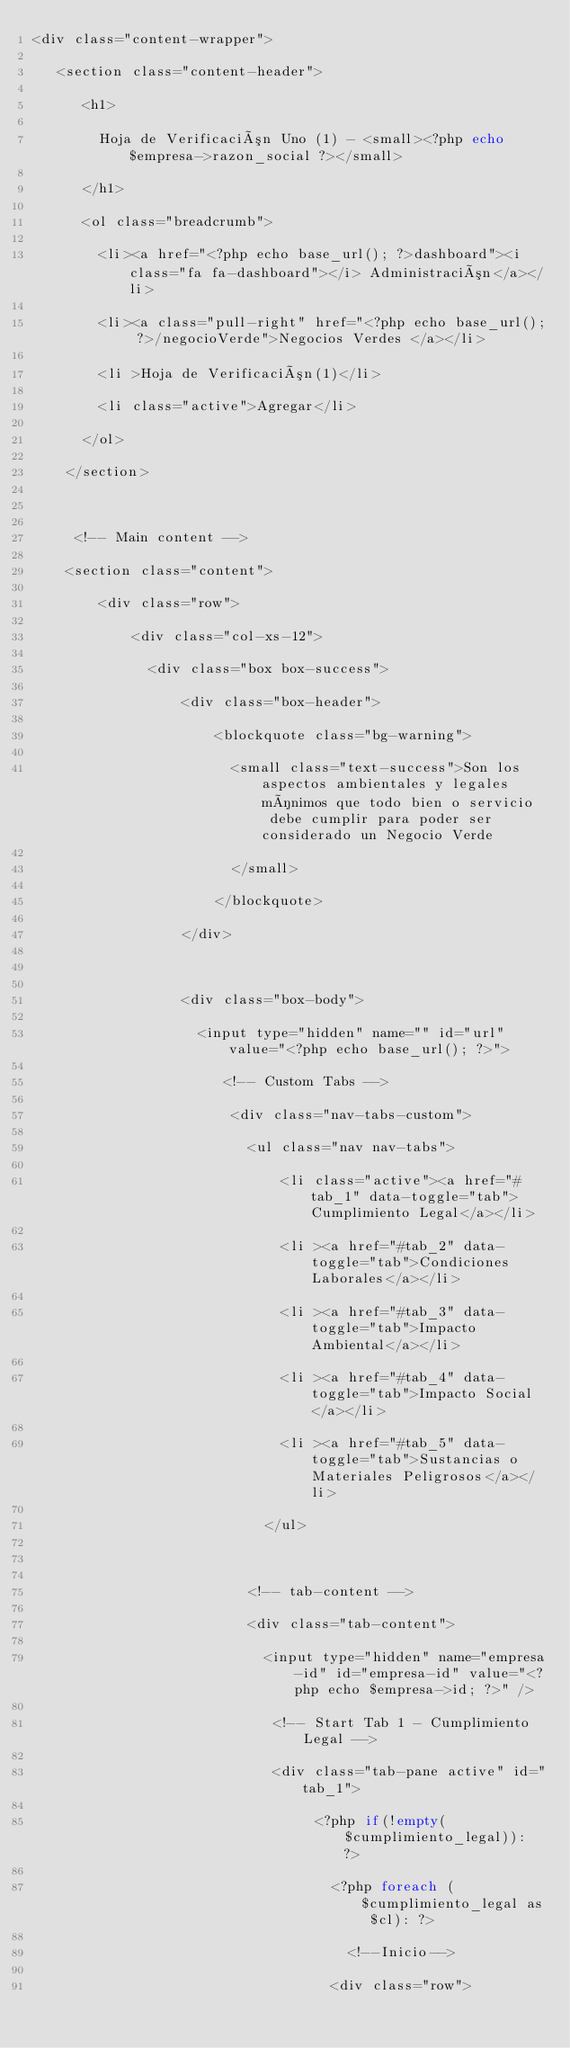Convert code to text. <code><loc_0><loc_0><loc_500><loc_500><_PHP_><div class="content-wrapper">
   <section class="content-header">
      <h1>
        Hoja de Verificación Uno (1) - <small><?php echo $empresa->razon_social ?></small>
      </h1>
      <ol class="breadcrumb">
        <li><a href="<?php echo base_url(); ?>dashboard"><i class="fa fa-dashboard"></i> Administración</a></li>
        <li><a class="pull-right" href="<?php echo base_url(); ?>/negocioVerde">Negocios Verdes </a></li>
        <li >Hoja de Verificación(1)</li>
        <li class="active">Agregar</li>
      </ol>
    </section>

     <!-- Main content -->
    <section class="content">
        <div class="row">
            <div class="col-xs-12">
              <div class="box box-success">
                  <div class="box-header">
                      <blockquote class="bg-warning">
                        <small class="text-success">Son los aspectos ambientales y legales mínimos que todo bien o servicio  debe cumplir para poder ser considerado un Negocio Verde
                        </small>
                      </blockquote>
                  </div>

                  <div class="box-body">
                    <input type="hidden" name="" id="url" value="<?php echo base_url(); ?>">
                       <!-- Custom Tabs -->
                        <div class="nav-tabs-custom">
                          <ul class="nav nav-tabs">
                              <li class="active"><a href="#tab_1" data-toggle="tab">Cumplimiento Legal</a></li>
                              <li ><a href="#tab_2" data-toggle="tab">Condiciones Laborales</a></li>
                              <li ><a href="#tab_3" data-toggle="tab">Impacto Ambiental</a></li>
                              <li ><a href="#tab_4" data-toggle="tab">Impacto Social</a></li>
                              <li ><a href="#tab_5" data-toggle="tab">Sustancias o Materiales Peligrosos</a></li>
                            </ul>
                          
                          <!-- tab-content --> 
                          <div class="tab-content">
                            <input type="hidden" name="empresa-id" id="empresa-id" value="<?php echo $empresa->id; ?>" />
                             <!-- Start Tab 1 - Cumplimiento Legal -->
                             <div class="tab-pane active" id="tab_1">
                                  <?php if(!empty($cumplimiento_legal)): ?>
                                    <?php foreach ($cumplimiento_legal as $cl): ?> 
                                      <!--Inicio-->
                                    <div class="row"></code> 